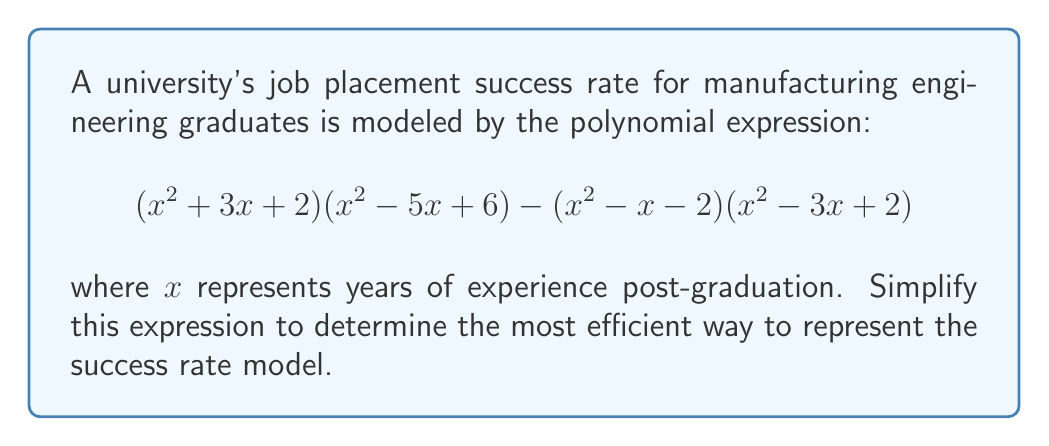Can you answer this question? Let's approach this step-by-step:

1) First, let's expand $(x^2 + 3x + 2)(x^2 - 5x + 6)$:
   $$(x^4 - 5x^3 + 6x^2) + (3x^3 - 15x^2 + 18x) + (2x^2 - 10x + 12)$$
   $$= x^4 - 2x^3 - 7x^2 + 18x + 12$$

2) Now, let's expand $(x^2 - x - 2)(x^2 - 3x + 2)$:
   $$(x^4 - 3x^3 + 2x^2) + (-x^3 + 3x^2 - 2x) + (-2x^2 + 6x - 4)$$
   $$= x^4 - 4x^3 + 3x^2 + 4x - 4$$

3) Now, we subtract the second expansion from the first:
   $$(x^4 - 2x^3 - 7x^2 + 18x + 12) - (x^4 - 4x^3 + 3x^2 + 4x - 4)$$

4) Simplifying:
   $$x^4 - 2x^3 - 7x^2 + 18x + 12 - x^4 + 4x^3 - 3x^2 - 4x + 4$$
   $$= 2x^3 - 10x^2 + 14x + 8$$

5) This can be factored further:
   $$2(x^3 - 5x^2 + 7x + 4)$$

6) The cubic expression inside the parentheses can be factored:
   $$2(x + 1)(x^2 - 6x + 4)$$

7) The quadratic term can be factored further:
   $$2(x + 1)(x - 2)(x - 4)$$

This is the most simplified form of the expression.
Answer: $$2(x + 1)(x - 2)(x - 4)$$ 